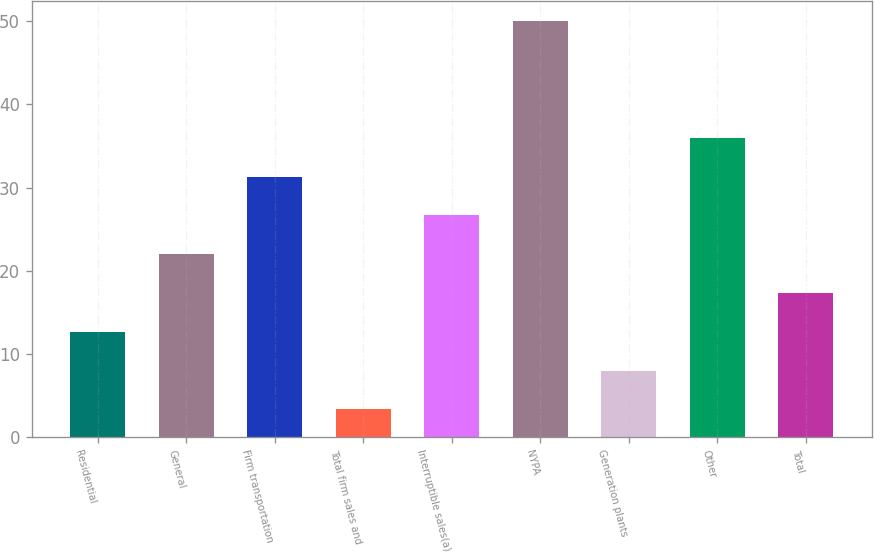<chart> <loc_0><loc_0><loc_500><loc_500><bar_chart><fcel>Residential<fcel>General<fcel>Firm transportation<fcel>Total firm sales and<fcel>Interruptible sales(a)<fcel>NYPA<fcel>Generation plants<fcel>Other<fcel>Total<nl><fcel>12.64<fcel>21.98<fcel>31.32<fcel>3.3<fcel>26.65<fcel>50<fcel>7.97<fcel>35.99<fcel>17.31<nl></chart> 